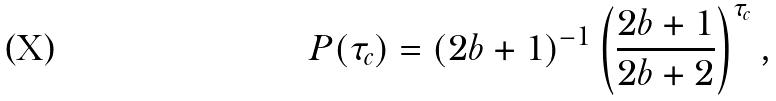<formula> <loc_0><loc_0><loc_500><loc_500>P ( \tau _ { c } ) = ( 2 b + 1 ) ^ { - 1 } \left ( \frac { 2 b + 1 } { 2 b + 2 } \right ) ^ { \tau _ { c } } ,</formula> 